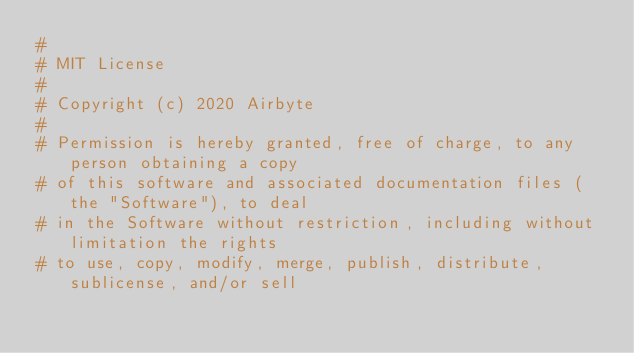Convert code to text. <code><loc_0><loc_0><loc_500><loc_500><_Python_>#
# MIT License
#
# Copyright (c) 2020 Airbyte
#
# Permission is hereby granted, free of charge, to any person obtaining a copy
# of this software and associated documentation files (the "Software"), to deal
# in the Software without restriction, including without limitation the rights
# to use, copy, modify, merge, publish, distribute, sublicense, and/or sell</code> 